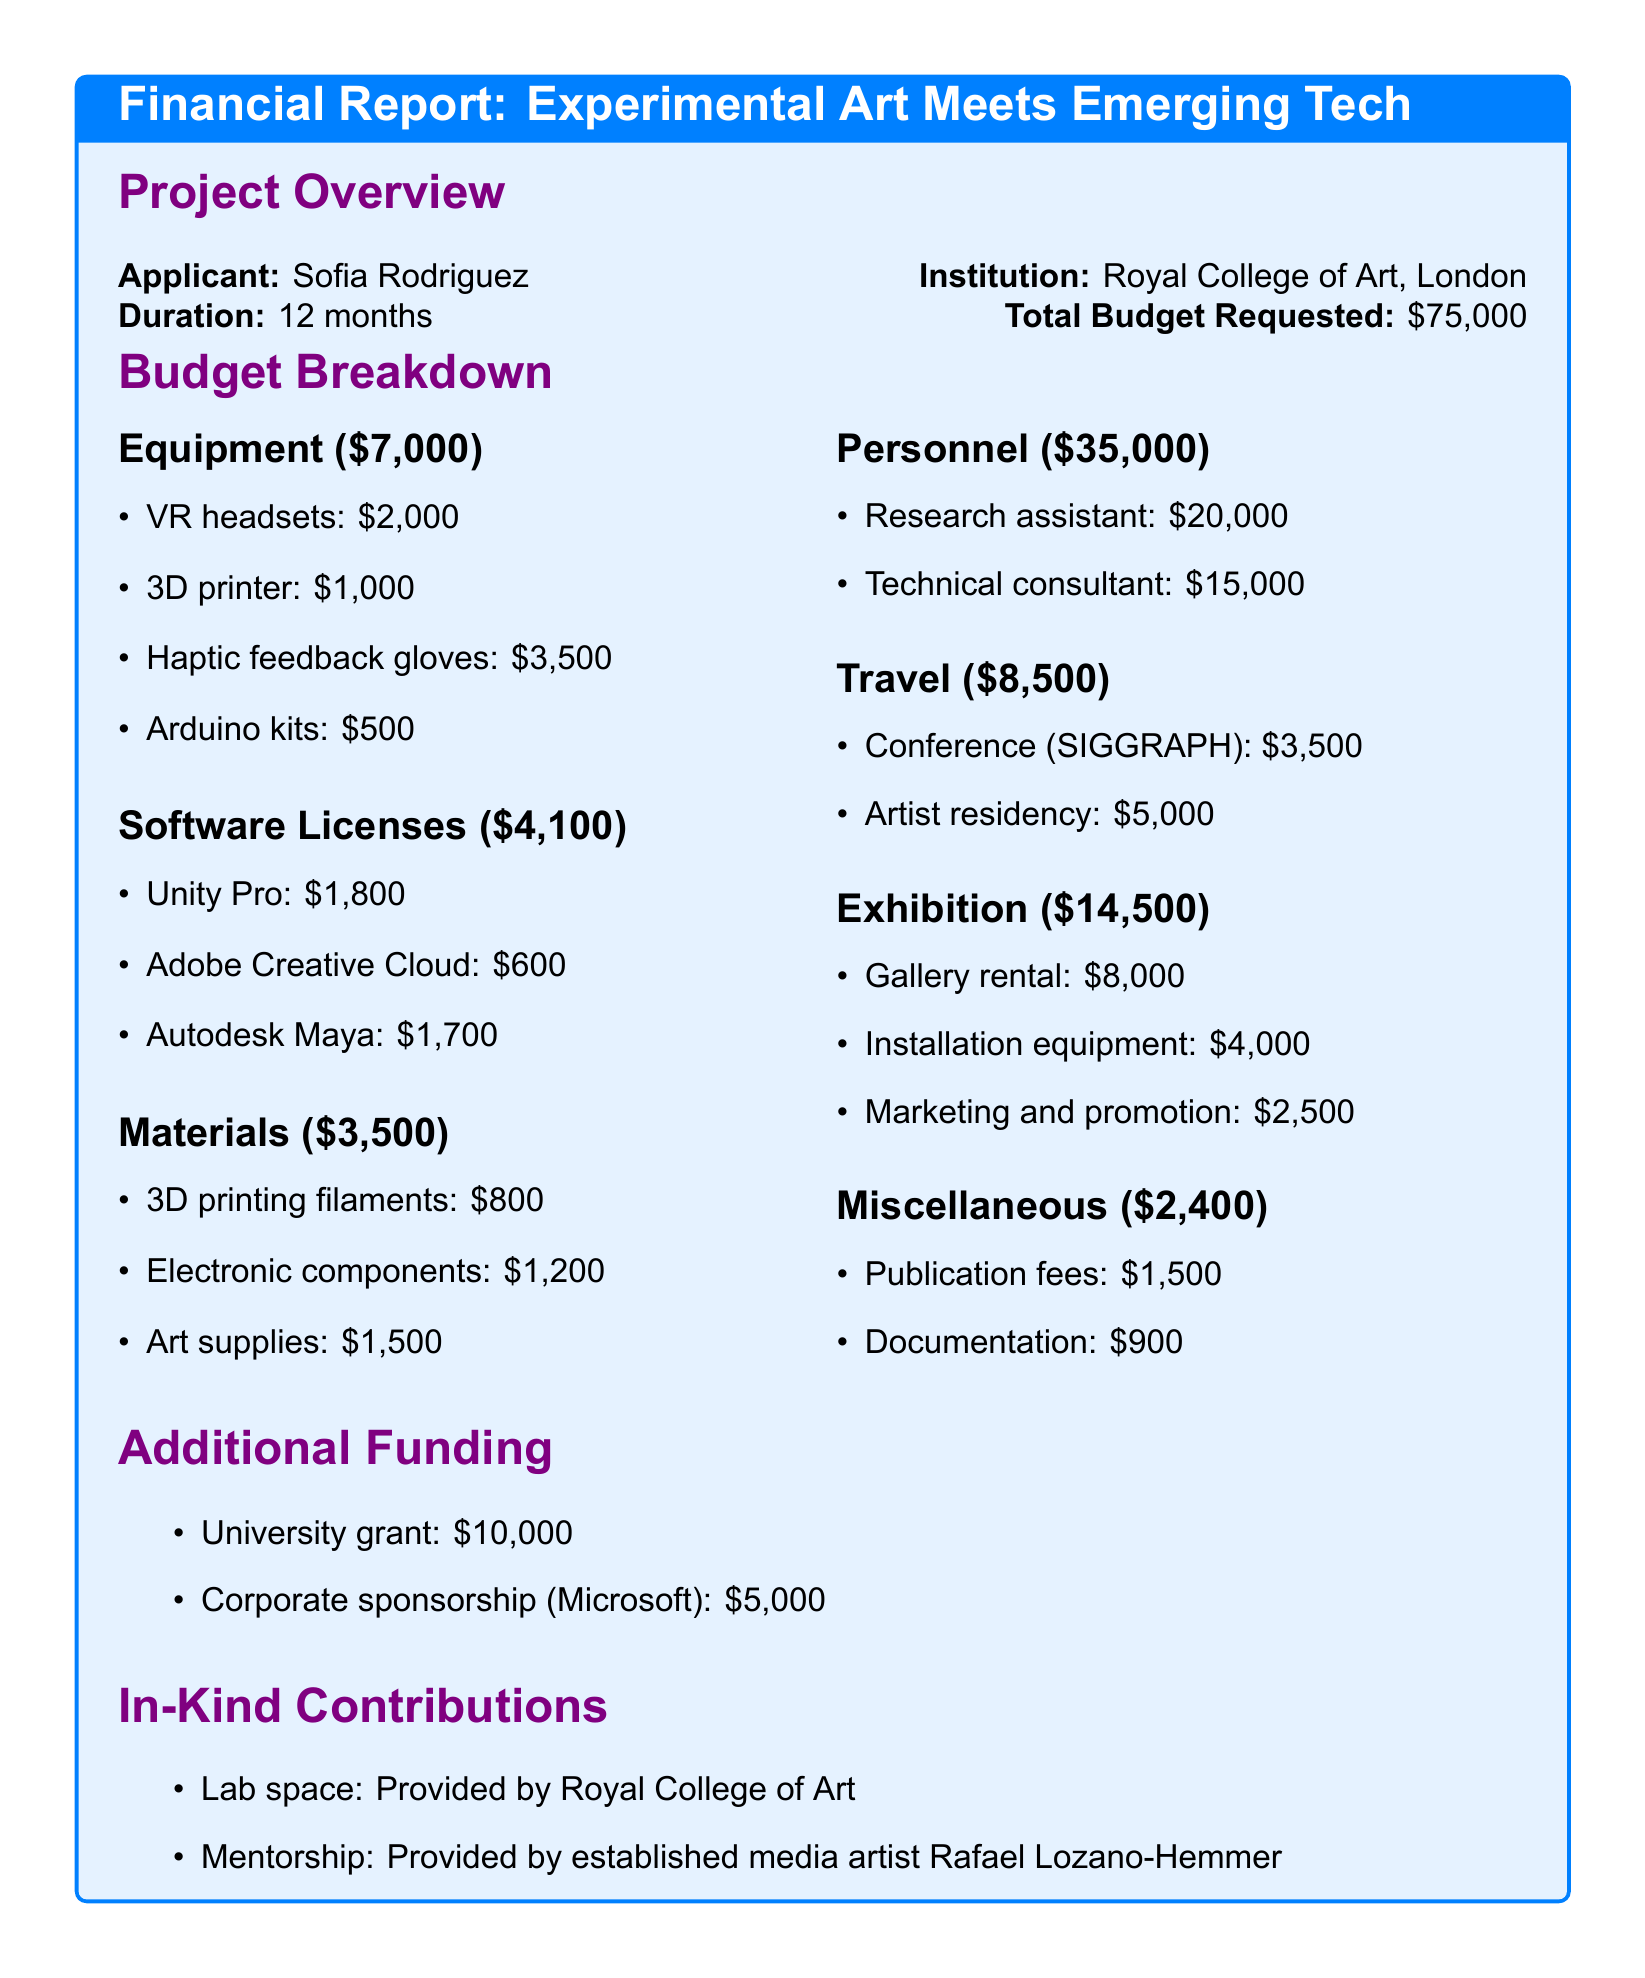What is the project title? The project title is listed at the beginning of the document.
Answer: Experimental Art Meets Emerging Tech: A Multisensory Experience How much funding is requested for software licenses? The software licenses budget is detailed in the budget breakdown section.
Answer: $4,100 Who is the applicant? The applicant's name is stated in the project overview.
Answer: Sofia Rodriguez What is the total budget requested? The total budget requested is highlighted in the project overview section.
Answer: $75,000 How much is allocated for personnel costs? Personnel costs are broken down in the budget, representing a specific category in the breakdown.
Answer: $35,000 What is the amount for in-kind contributions? In-kind contributions are mentioned as a part of the funding sources, but there is no specific total provided for them.
Answer: Not specified Which company provided corporate sponsorship? The corporate sponsorship information is included in the additional funding section.
Answer: Microsoft What is included in the exhibition costs? Exhibition costs contain various items detailed in the budget breakdown.
Answer: Gallery rental, installation equipment, marketing and promotion What is the duration of the project? The duration of the project is indicated in the project overview.
Answer: 12 months 